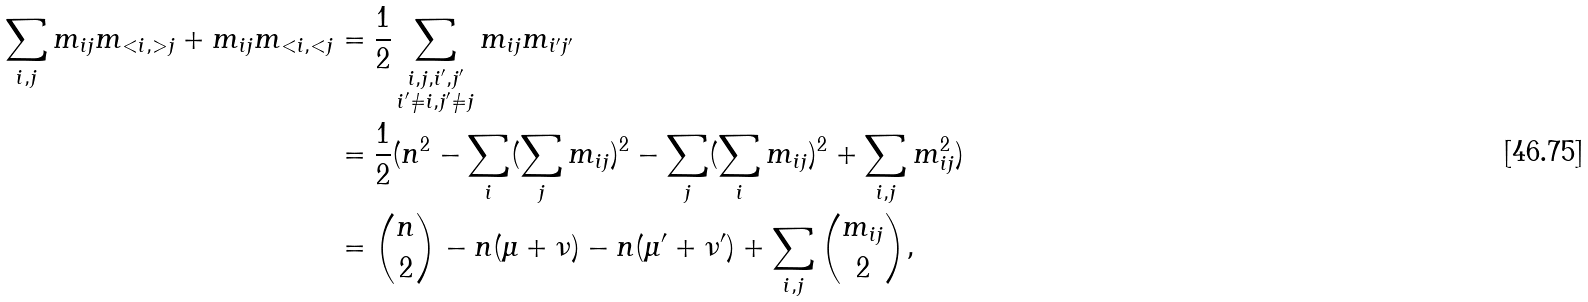<formula> <loc_0><loc_0><loc_500><loc_500>\sum _ { i , j } m _ { i j } m _ { < i , > j } + m _ { i j } m _ { < i , < j } & = \frac { 1 } { 2 } \sum _ { \substack { i , j , i ^ { \prime } , j ^ { \prime } \\ i ^ { \prime } \neq i , j ^ { \prime } \neq j } } m _ { i j } m _ { i ^ { \prime } j ^ { \prime } } \\ & = \frac { 1 } { 2 } ( n ^ { 2 } - \sum _ { i } ( \sum _ { j } m _ { i j } ) ^ { 2 } - \sum _ { j } ( \sum _ { i } m _ { i j } ) ^ { 2 } + \sum _ { i , j } m _ { i j } ^ { 2 } ) \\ & = \binom { n } { 2 } - n ( \mu + \nu ) - n ( \mu ^ { \prime } + \nu ^ { \prime } ) + \sum _ { i , j } \binom { m _ { i j } } { 2 } ,</formula> 